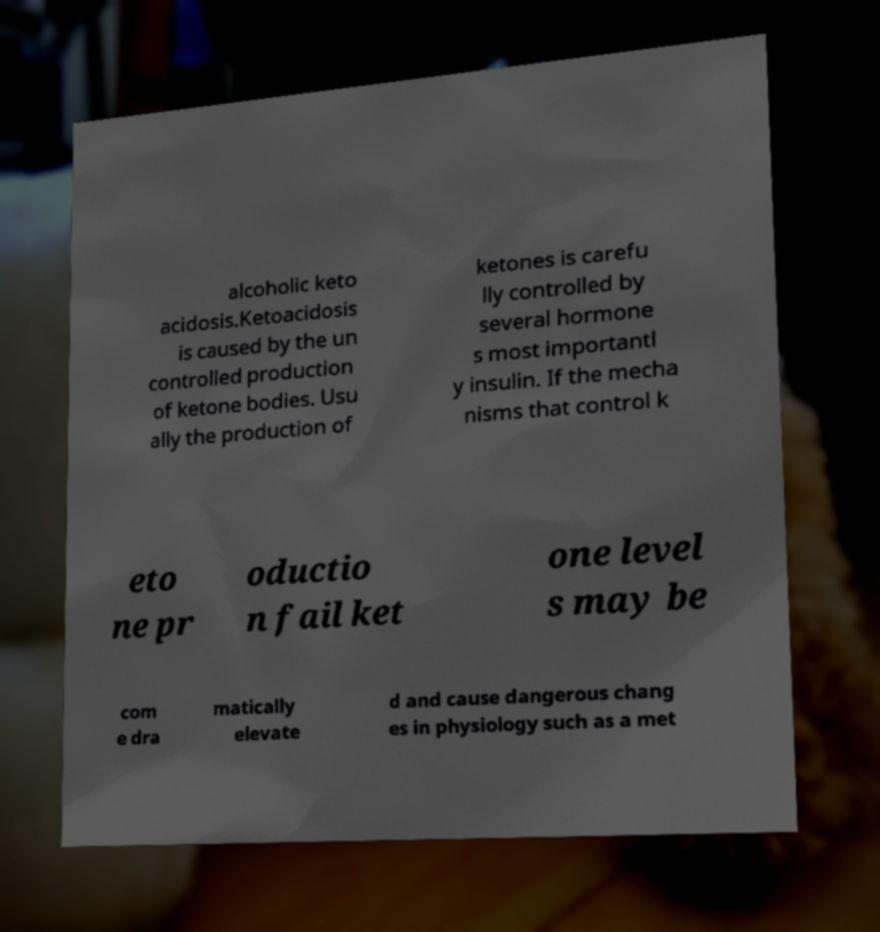Can you read and provide the text displayed in the image?This photo seems to have some interesting text. Can you extract and type it out for me? alcoholic keto acidosis.Ketoacidosis is caused by the un controlled production of ketone bodies. Usu ally the production of ketones is carefu lly controlled by several hormone s most importantl y insulin. If the mecha nisms that control k eto ne pr oductio n fail ket one level s may be com e dra matically elevate d and cause dangerous chang es in physiology such as a met 